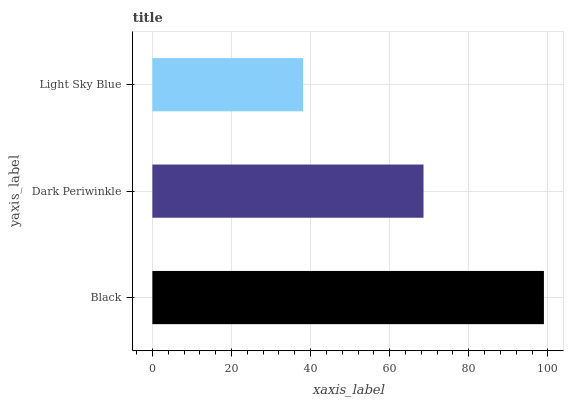Is Light Sky Blue the minimum?
Answer yes or no. Yes. Is Black the maximum?
Answer yes or no. Yes. Is Dark Periwinkle the minimum?
Answer yes or no. No. Is Dark Periwinkle the maximum?
Answer yes or no. No. Is Black greater than Dark Periwinkle?
Answer yes or no. Yes. Is Dark Periwinkle less than Black?
Answer yes or no. Yes. Is Dark Periwinkle greater than Black?
Answer yes or no. No. Is Black less than Dark Periwinkle?
Answer yes or no. No. Is Dark Periwinkle the high median?
Answer yes or no. Yes. Is Dark Periwinkle the low median?
Answer yes or no. Yes. Is Light Sky Blue the high median?
Answer yes or no. No. Is Black the low median?
Answer yes or no. No. 